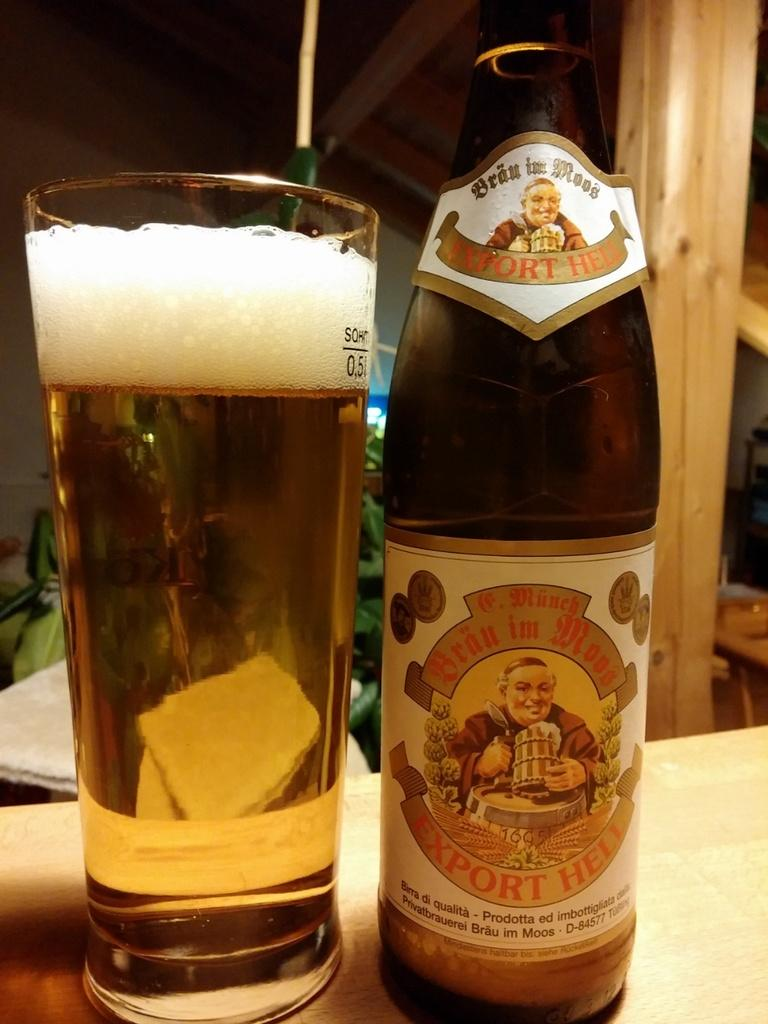<image>
Share a concise interpretation of the image provided. Export Hell beer bottle next to a cup of beer. 